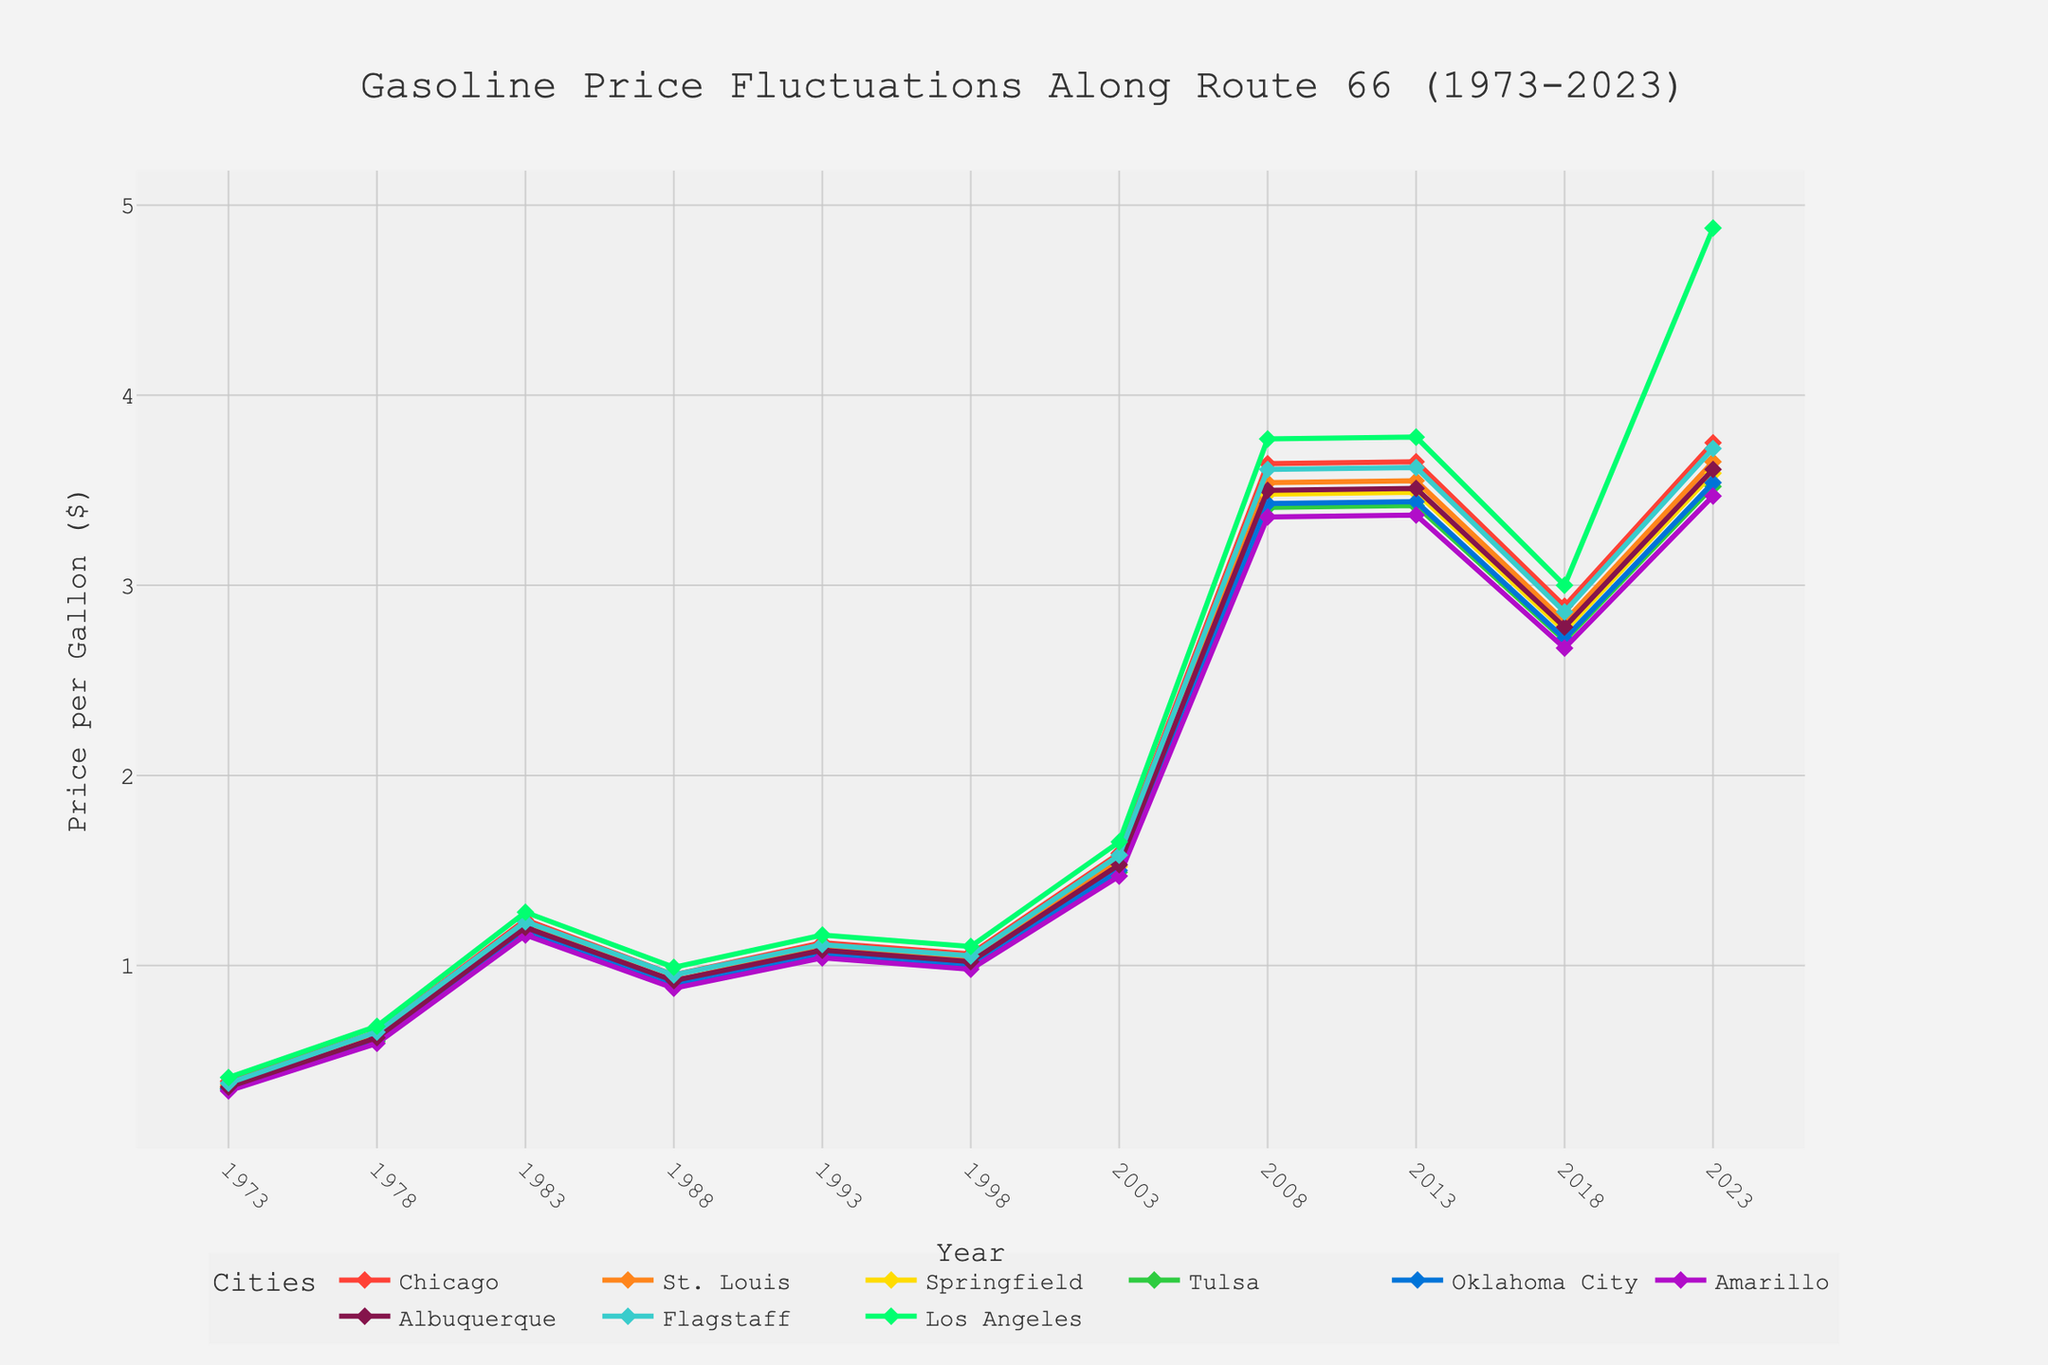What was the gasoline price in Chicago in 1973 and 2023? To find the gasoline prices in Chicago for the specified years, look at the chart where "Chicago" is plotted. Match the price on the y-axis for the years 1973 and 2023. In 1973, the price is around $0.39, and in 2023, it is around $3.75.
Answer: $0.39 in 1973 and $3.75 in 2023 Which city had the highest gasoline price in 2023? Check the line positions on the chart for 2023. The city line intersecting the highest point on the y-axis indicates the highest price. Los Angeles has the highest price in 2023.
Answer: Los Angeles Between which years did Tulsa see the most significant increase in gasoline prices? Look at the "Tulsa" line and identify the steepest slope between two points. The steepest increase for Tulsa occurs between 2003 and 2008.
Answer: 2003-2008 Compare the gasoline prices in St. Louis and Albuquerque in 1998. Which city had a higher price and by how much? Identify both "St. Louis" and "Albuquerque" lines for the year 1998. St. Louis is at $1.03, and Albuquerque is at $1.02. The difference is $1.03 - $1.02 = $0.01.
Answer: St. Louis by $0.01 What is the average gasoline price across all cities in 1983? Add up the prices for all the cities in 1983 and divide by the number of cities. Prices: $1.24 + $1.21 + $1.19 + $1.17 + $1.18 + $1.16 + $1.20 + $1.23 + $1.28 = $10.86. There are 9 cities, so the average price = $10.86 / 9 ≈ $1.21.
Answer: $1.21 How much did gasoline prices change in Albuquerque from 2008 to 2018? Find the prices for Albuquerque in 2008 and 2018. Subtract the 2018 price from the 2008 price. Albuquerque's prices are $3.50 in 2008 and $2.78 in 2018. The change is $3.50 - $2.78 = $0.72.
Answer: Decreased by $0.72 Which city had the least fluctuation in gasoline prices between 1973 and 2023, and how can you tell? Inspect the lines' smoothness and steepness. The city with the least fluctuation will have the least steepness and more uniform changes over time. Oklahoma City's line shows the least deviation and fluctuation.
Answer: Oklahoma City In which year did gasoline prices in Los Angeles peak, and what was the price? Look for the highest point on the "Los Angeles" line. The peak occurs in 2023 at approximately $4.88.
Answer: 2023 at $4.88 